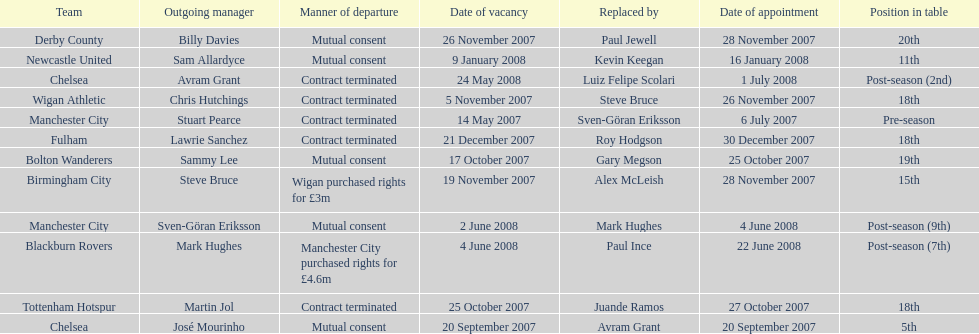What was the top team according to position in table called? Manchester City. 